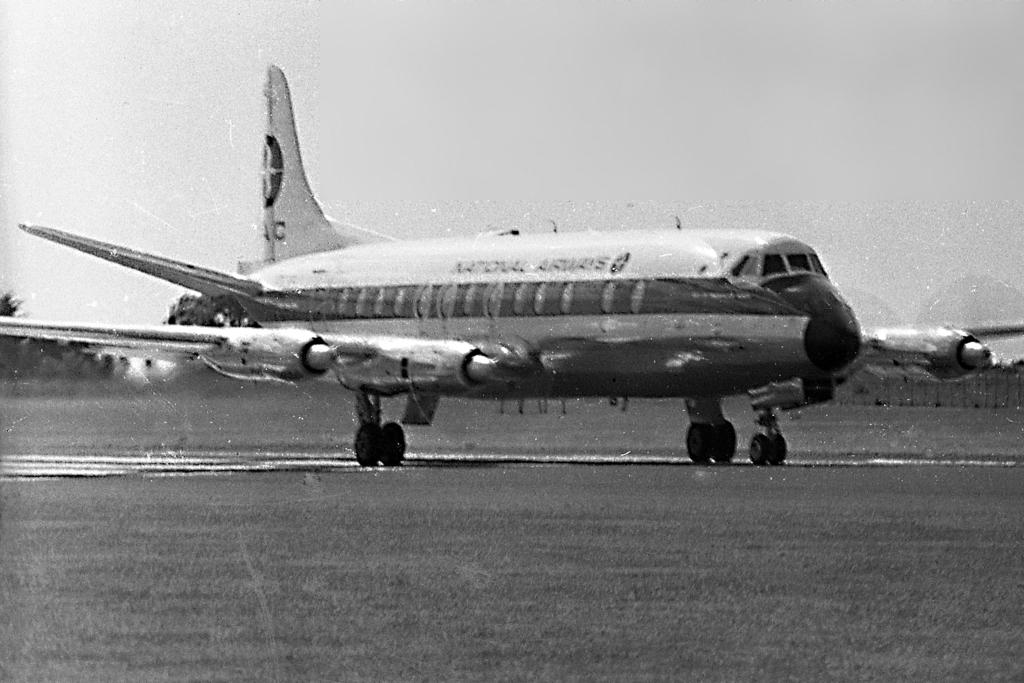What is the main subject of the image? The main subject of the image is an aircraft. Where is the aircraft located in the image? The aircraft is on the road in the image. What can be seen in the background of the image? There are many trees and the sky visible in the background of the image. How many beams are supporting the aircraft in the image? There are no beams supporting the aircraft in the image; it is on the road. What type of spiders can be seen crawling on the aircraft in the image? There are no spiders present in the image, and therefore no such activity can be observed. 